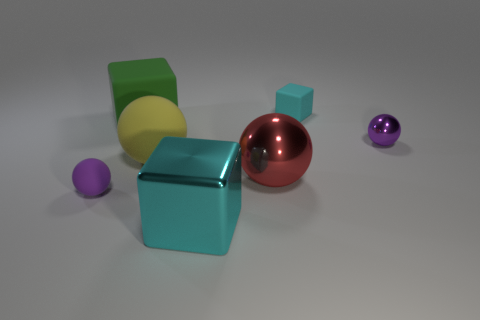What is the size of the purple object left of the purple thing to the right of the cyan object in front of the big yellow matte ball?
Keep it short and to the point. Small. What is the shape of the cyan thing that is the same size as the yellow sphere?
Ensure brevity in your answer.  Cube. The large green object has what shape?
Offer a very short reply. Cube. Are the tiny ball right of the cyan matte cube and the big red sphere made of the same material?
Offer a terse response. Yes. There is a purple object to the right of the cyan object that is behind the big red metallic sphere; how big is it?
Offer a terse response. Small. There is a sphere that is right of the large metal cube and behind the red metallic object; what is its color?
Provide a succinct answer. Purple. What is the material of the green cube that is the same size as the yellow rubber thing?
Your response must be concise. Rubber. How many other things are the same material as the large yellow sphere?
Give a very brief answer. 3. There is a thing left of the big green rubber thing; does it have the same color as the shiny sphere that is in front of the tiny shiny object?
Offer a very short reply. No. There is a metal thing in front of the purple thing that is on the left side of the big green rubber cube; what shape is it?
Your answer should be compact. Cube. 